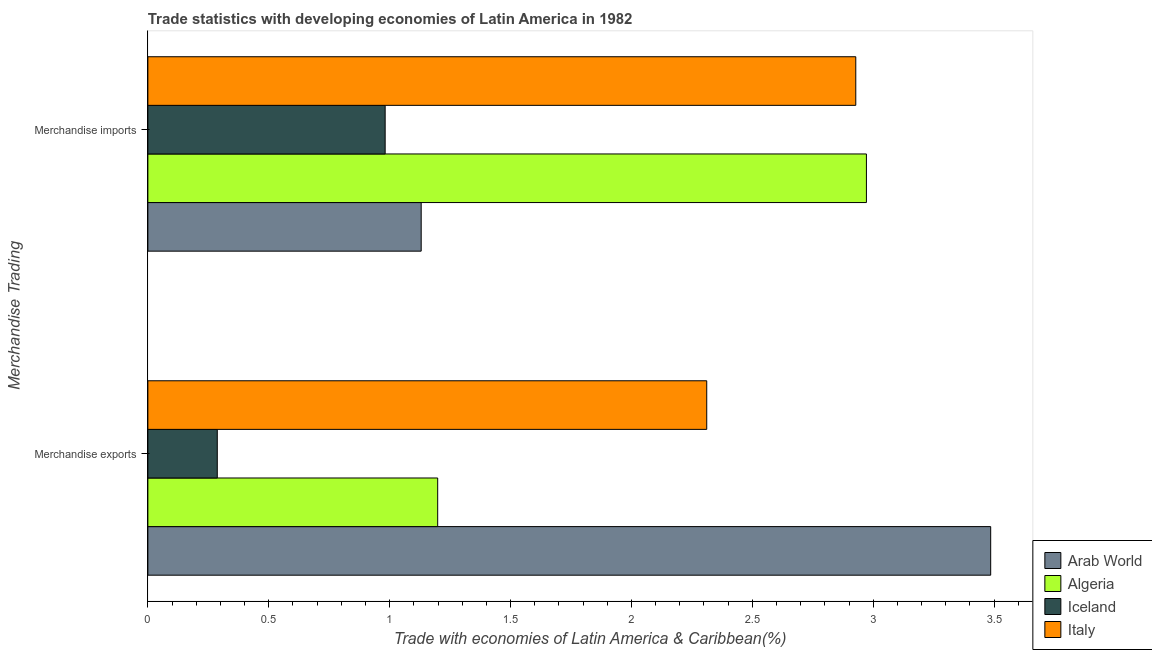How many different coloured bars are there?
Give a very brief answer. 4. Are the number of bars per tick equal to the number of legend labels?
Provide a short and direct response. Yes. What is the merchandise exports in Iceland?
Provide a short and direct response. 0.29. Across all countries, what is the maximum merchandise exports?
Your answer should be compact. 3.49. Across all countries, what is the minimum merchandise imports?
Provide a succinct answer. 0.98. In which country was the merchandise imports maximum?
Provide a succinct answer. Algeria. What is the total merchandise imports in the graph?
Offer a very short reply. 8.01. What is the difference between the merchandise exports in Arab World and that in Algeria?
Your answer should be very brief. 2.29. What is the difference between the merchandise imports in Italy and the merchandise exports in Algeria?
Provide a succinct answer. 1.73. What is the average merchandise exports per country?
Offer a terse response. 1.82. What is the difference between the merchandise exports and merchandise imports in Italy?
Offer a terse response. -0.62. In how many countries, is the merchandise imports greater than 1.6 %?
Ensure brevity in your answer.  2. What is the ratio of the merchandise exports in Iceland to that in Arab World?
Keep it short and to the point. 0.08. In how many countries, is the merchandise imports greater than the average merchandise imports taken over all countries?
Your answer should be compact. 2. What does the 2nd bar from the top in Merchandise imports represents?
Offer a terse response. Iceland. What does the 2nd bar from the bottom in Merchandise exports represents?
Offer a terse response. Algeria. How many bars are there?
Give a very brief answer. 8. How many countries are there in the graph?
Ensure brevity in your answer.  4. Where does the legend appear in the graph?
Your response must be concise. Bottom right. How many legend labels are there?
Offer a very short reply. 4. How are the legend labels stacked?
Offer a terse response. Vertical. What is the title of the graph?
Your answer should be very brief. Trade statistics with developing economies of Latin America in 1982. Does "Bangladesh" appear as one of the legend labels in the graph?
Ensure brevity in your answer.  No. What is the label or title of the X-axis?
Make the answer very short. Trade with economies of Latin America & Caribbean(%). What is the label or title of the Y-axis?
Offer a very short reply. Merchandise Trading. What is the Trade with economies of Latin America & Caribbean(%) in Arab World in Merchandise exports?
Give a very brief answer. 3.49. What is the Trade with economies of Latin America & Caribbean(%) in Algeria in Merchandise exports?
Give a very brief answer. 1.2. What is the Trade with economies of Latin America & Caribbean(%) of Iceland in Merchandise exports?
Your answer should be very brief. 0.29. What is the Trade with economies of Latin America & Caribbean(%) of Italy in Merchandise exports?
Your response must be concise. 2.31. What is the Trade with economies of Latin America & Caribbean(%) of Arab World in Merchandise imports?
Give a very brief answer. 1.13. What is the Trade with economies of Latin America & Caribbean(%) in Algeria in Merchandise imports?
Provide a succinct answer. 2.97. What is the Trade with economies of Latin America & Caribbean(%) of Iceland in Merchandise imports?
Your answer should be very brief. 0.98. What is the Trade with economies of Latin America & Caribbean(%) of Italy in Merchandise imports?
Provide a short and direct response. 2.93. Across all Merchandise Trading, what is the maximum Trade with economies of Latin America & Caribbean(%) in Arab World?
Your answer should be very brief. 3.49. Across all Merchandise Trading, what is the maximum Trade with economies of Latin America & Caribbean(%) of Algeria?
Your answer should be compact. 2.97. Across all Merchandise Trading, what is the maximum Trade with economies of Latin America & Caribbean(%) of Iceland?
Make the answer very short. 0.98. Across all Merchandise Trading, what is the maximum Trade with economies of Latin America & Caribbean(%) in Italy?
Provide a short and direct response. 2.93. Across all Merchandise Trading, what is the minimum Trade with economies of Latin America & Caribbean(%) in Arab World?
Provide a succinct answer. 1.13. Across all Merchandise Trading, what is the minimum Trade with economies of Latin America & Caribbean(%) in Algeria?
Provide a short and direct response. 1.2. Across all Merchandise Trading, what is the minimum Trade with economies of Latin America & Caribbean(%) of Iceland?
Make the answer very short. 0.29. Across all Merchandise Trading, what is the minimum Trade with economies of Latin America & Caribbean(%) of Italy?
Offer a terse response. 2.31. What is the total Trade with economies of Latin America & Caribbean(%) in Arab World in the graph?
Keep it short and to the point. 4.62. What is the total Trade with economies of Latin America & Caribbean(%) in Algeria in the graph?
Offer a very short reply. 4.17. What is the total Trade with economies of Latin America & Caribbean(%) of Iceland in the graph?
Provide a succinct answer. 1.27. What is the total Trade with economies of Latin America & Caribbean(%) of Italy in the graph?
Give a very brief answer. 5.24. What is the difference between the Trade with economies of Latin America & Caribbean(%) of Arab World in Merchandise exports and that in Merchandise imports?
Ensure brevity in your answer.  2.36. What is the difference between the Trade with economies of Latin America & Caribbean(%) of Algeria in Merchandise exports and that in Merchandise imports?
Give a very brief answer. -1.77. What is the difference between the Trade with economies of Latin America & Caribbean(%) in Iceland in Merchandise exports and that in Merchandise imports?
Your answer should be compact. -0.69. What is the difference between the Trade with economies of Latin America & Caribbean(%) in Italy in Merchandise exports and that in Merchandise imports?
Offer a terse response. -0.62. What is the difference between the Trade with economies of Latin America & Caribbean(%) of Arab World in Merchandise exports and the Trade with economies of Latin America & Caribbean(%) of Algeria in Merchandise imports?
Ensure brevity in your answer.  0.51. What is the difference between the Trade with economies of Latin America & Caribbean(%) in Arab World in Merchandise exports and the Trade with economies of Latin America & Caribbean(%) in Iceland in Merchandise imports?
Your answer should be very brief. 2.5. What is the difference between the Trade with economies of Latin America & Caribbean(%) in Arab World in Merchandise exports and the Trade with economies of Latin America & Caribbean(%) in Italy in Merchandise imports?
Your answer should be compact. 0.56. What is the difference between the Trade with economies of Latin America & Caribbean(%) in Algeria in Merchandise exports and the Trade with economies of Latin America & Caribbean(%) in Iceland in Merchandise imports?
Keep it short and to the point. 0.22. What is the difference between the Trade with economies of Latin America & Caribbean(%) of Algeria in Merchandise exports and the Trade with economies of Latin America & Caribbean(%) of Italy in Merchandise imports?
Offer a terse response. -1.73. What is the difference between the Trade with economies of Latin America & Caribbean(%) in Iceland in Merchandise exports and the Trade with economies of Latin America & Caribbean(%) in Italy in Merchandise imports?
Provide a short and direct response. -2.64. What is the average Trade with economies of Latin America & Caribbean(%) in Arab World per Merchandise Trading?
Your answer should be very brief. 2.31. What is the average Trade with economies of Latin America & Caribbean(%) in Algeria per Merchandise Trading?
Your answer should be compact. 2.09. What is the average Trade with economies of Latin America & Caribbean(%) of Iceland per Merchandise Trading?
Ensure brevity in your answer.  0.63. What is the average Trade with economies of Latin America & Caribbean(%) in Italy per Merchandise Trading?
Provide a short and direct response. 2.62. What is the difference between the Trade with economies of Latin America & Caribbean(%) of Arab World and Trade with economies of Latin America & Caribbean(%) of Algeria in Merchandise exports?
Ensure brevity in your answer.  2.29. What is the difference between the Trade with economies of Latin America & Caribbean(%) of Arab World and Trade with economies of Latin America & Caribbean(%) of Iceland in Merchandise exports?
Provide a short and direct response. 3.2. What is the difference between the Trade with economies of Latin America & Caribbean(%) in Arab World and Trade with economies of Latin America & Caribbean(%) in Italy in Merchandise exports?
Give a very brief answer. 1.17. What is the difference between the Trade with economies of Latin America & Caribbean(%) in Algeria and Trade with economies of Latin America & Caribbean(%) in Iceland in Merchandise exports?
Give a very brief answer. 0.91. What is the difference between the Trade with economies of Latin America & Caribbean(%) in Algeria and Trade with economies of Latin America & Caribbean(%) in Italy in Merchandise exports?
Offer a terse response. -1.11. What is the difference between the Trade with economies of Latin America & Caribbean(%) in Iceland and Trade with economies of Latin America & Caribbean(%) in Italy in Merchandise exports?
Your response must be concise. -2.02. What is the difference between the Trade with economies of Latin America & Caribbean(%) of Arab World and Trade with economies of Latin America & Caribbean(%) of Algeria in Merchandise imports?
Your answer should be compact. -1.84. What is the difference between the Trade with economies of Latin America & Caribbean(%) of Arab World and Trade with economies of Latin America & Caribbean(%) of Iceland in Merchandise imports?
Your response must be concise. 0.15. What is the difference between the Trade with economies of Latin America & Caribbean(%) in Arab World and Trade with economies of Latin America & Caribbean(%) in Italy in Merchandise imports?
Provide a short and direct response. -1.8. What is the difference between the Trade with economies of Latin America & Caribbean(%) in Algeria and Trade with economies of Latin America & Caribbean(%) in Iceland in Merchandise imports?
Offer a very short reply. 1.99. What is the difference between the Trade with economies of Latin America & Caribbean(%) in Algeria and Trade with economies of Latin America & Caribbean(%) in Italy in Merchandise imports?
Your answer should be very brief. 0.04. What is the difference between the Trade with economies of Latin America & Caribbean(%) of Iceland and Trade with economies of Latin America & Caribbean(%) of Italy in Merchandise imports?
Make the answer very short. -1.95. What is the ratio of the Trade with economies of Latin America & Caribbean(%) in Arab World in Merchandise exports to that in Merchandise imports?
Your answer should be very brief. 3.08. What is the ratio of the Trade with economies of Latin America & Caribbean(%) in Algeria in Merchandise exports to that in Merchandise imports?
Give a very brief answer. 0.4. What is the ratio of the Trade with economies of Latin America & Caribbean(%) in Iceland in Merchandise exports to that in Merchandise imports?
Offer a terse response. 0.29. What is the ratio of the Trade with economies of Latin America & Caribbean(%) of Italy in Merchandise exports to that in Merchandise imports?
Your answer should be compact. 0.79. What is the difference between the highest and the second highest Trade with economies of Latin America & Caribbean(%) in Arab World?
Give a very brief answer. 2.36. What is the difference between the highest and the second highest Trade with economies of Latin America & Caribbean(%) of Algeria?
Your answer should be compact. 1.77. What is the difference between the highest and the second highest Trade with economies of Latin America & Caribbean(%) in Iceland?
Make the answer very short. 0.69. What is the difference between the highest and the second highest Trade with economies of Latin America & Caribbean(%) of Italy?
Ensure brevity in your answer.  0.62. What is the difference between the highest and the lowest Trade with economies of Latin America & Caribbean(%) of Arab World?
Offer a very short reply. 2.36. What is the difference between the highest and the lowest Trade with economies of Latin America & Caribbean(%) in Algeria?
Make the answer very short. 1.77. What is the difference between the highest and the lowest Trade with economies of Latin America & Caribbean(%) of Iceland?
Provide a short and direct response. 0.69. What is the difference between the highest and the lowest Trade with economies of Latin America & Caribbean(%) in Italy?
Your answer should be compact. 0.62. 